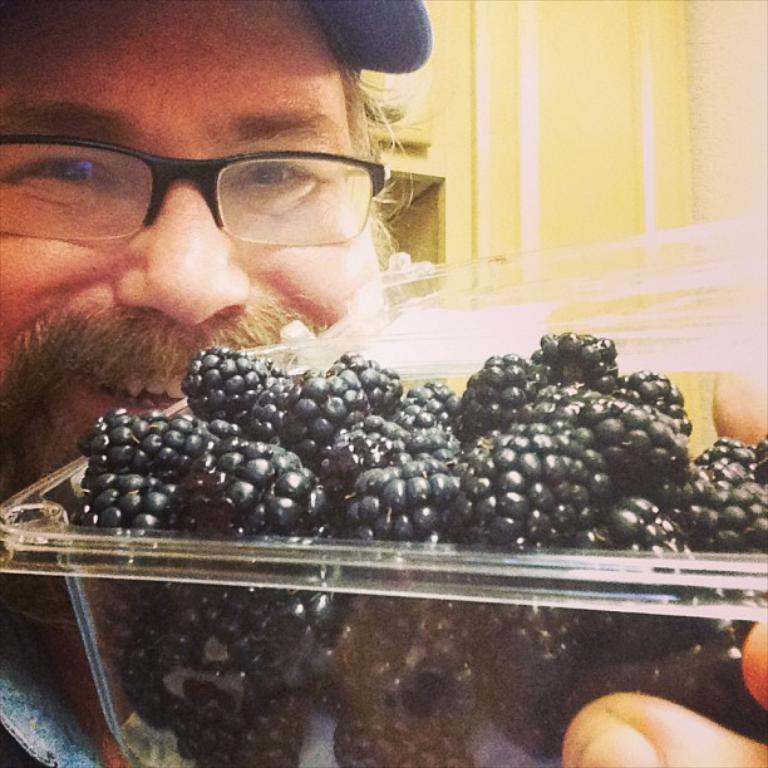What type of food is in the container in the image? There is fruit in a container in the image. Can you describe the person in the background of the image? There is a person holding the container in the background of the image. What can be seen behind the person in the image? There is a wall visible in the background of the image. What is the rate at which the person is walking in the image? There is no indication of the person walking or any rate in the image; they are holding the container. 